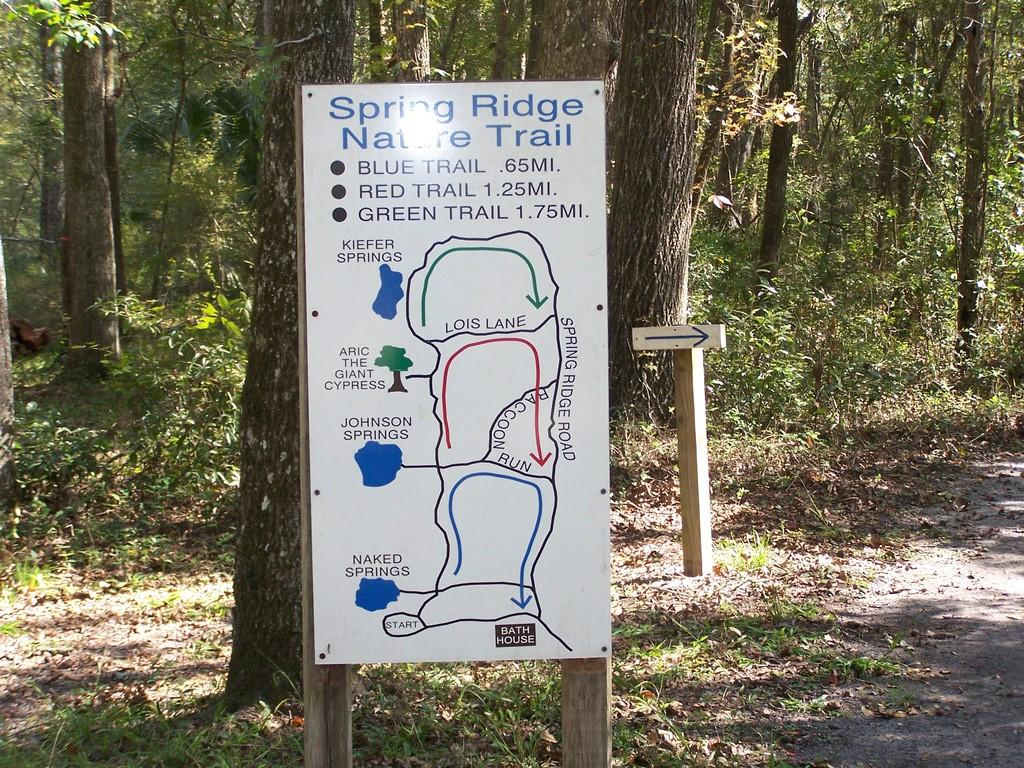What is constructed with wooden poles in the image? There are boards on wooden poles in the image. image. What type of vegetation is present in the image? Leaves and grass are visible in the image. What can be seen in the background of the image? There are trees in the background of the image. What is the name of the person standing next to the boards on wooden poles in the image? There is no person standing next to the boards on wooden poles in the image. What type of friction can be observed between the boards and wooden poles in the image? There is no indication of friction between the boards and wooden poles in the image, as they appear to be stationary. 